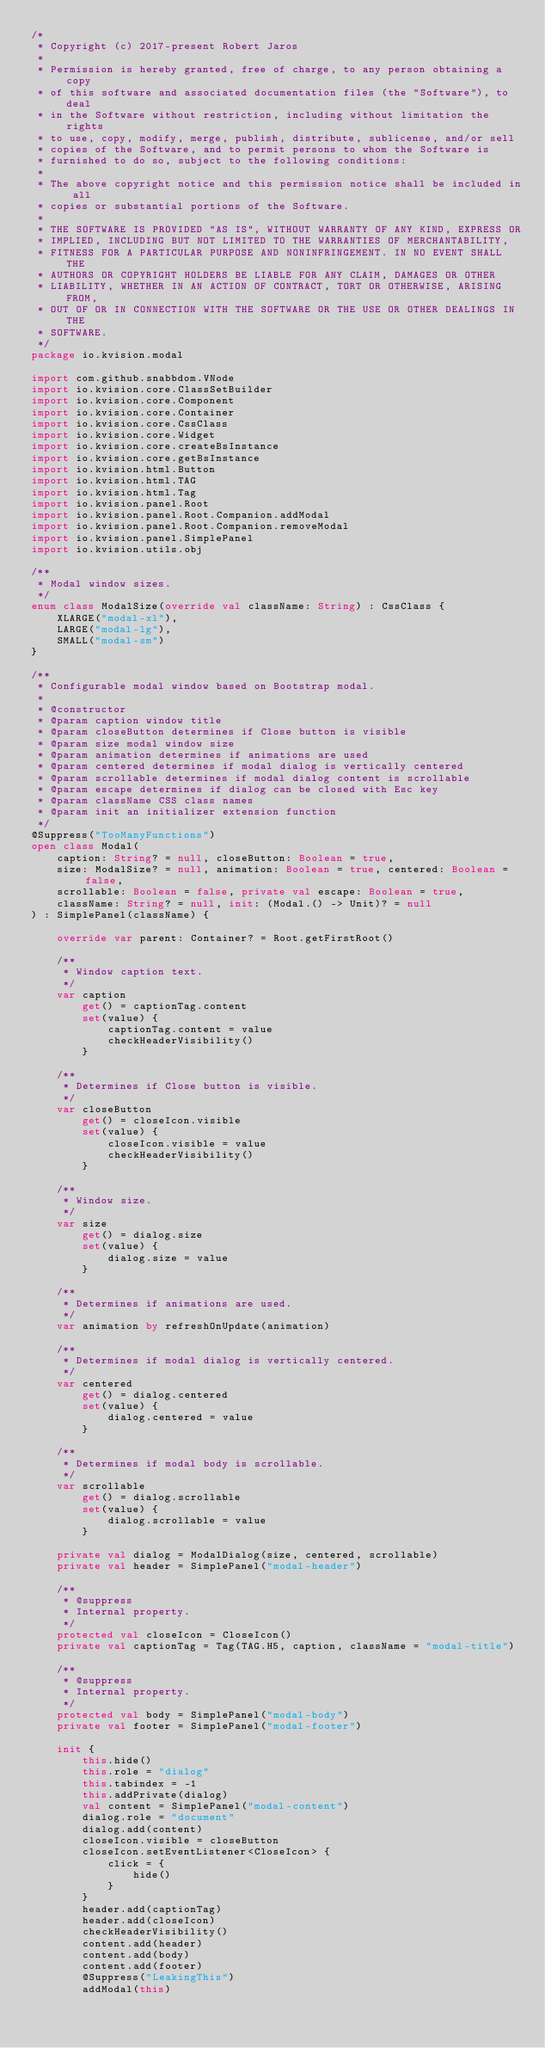<code> <loc_0><loc_0><loc_500><loc_500><_Kotlin_>/*
 * Copyright (c) 2017-present Robert Jaros
 *
 * Permission is hereby granted, free of charge, to any person obtaining a copy
 * of this software and associated documentation files (the "Software"), to deal
 * in the Software without restriction, including without limitation the rights
 * to use, copy, modify, merge, publish, distribute, sublicense, and/or sell
 * copies of the Software, and to permit persons to whom the Software is
 * furnished to do so, subject to the following conditions:
 *
 * The above copyright notice and this permission notice shall be included in all
 * copies or substantial portions of the Software.
 *
 * THE SOFTWARE IS PROVIDED "AS IS", WITHOUT WARRANTY OF ANY KIND, EXPRESS OR
 * IMPLIED, INCLUDING BUT NOT LIMITED TO THE WARRANTIES OF MERCHANTABILITY,
 * FITNESS FOR A PARTICULAR PURPOSE AND NONINFRINGEMENT. IN NO EVENT SHALL THE
 * AUTHORS OR COPYRIGHT HOLDERS BE LIABLE FOR ANY CLAIM, DAMAGES OR OTHER
 * LIABILITY, WHETHER IN AN ACTION OF CONTRACT, TORT OR OTHERWISE, ARISING FROM,
 * OUT OF OR IN CONNECTION WITH THE SOFTWARE OR THE USE OR OTHER DEALINGS IN THE
 * SOFTWARE.
 */
package io.kvision.modal

import com.github.snabbdom.VNode
import io.kvision.core.ClassSetBuilder
import io.kvision.core.Component
import io.kvision.core.Container
import io.kvision.core.CssClass
import io.kvision.core.Widget
import io.kvision.core.createBsInstance
import io.kvision.core.getBsInstance
import io.kvision.html.Button
import io.kvision.html.TAG
import io.kvision.html.Tag
import io.kvision.panel.Root
import io.kvision.panel.Root.Companion.addModal
import io.kvision.panel.Root.Companion.removeModal
import io.kvision.panel.SimplePanel
import io.kvision.utils.obj

/**
 * Modal window sizes.
 */
enum class ModalSize(override val className: String) : CssClass {
    XLARGE("modal-xl"),
    LARGE("modal-lg"),
    SMALL("modal-sm")
}

/**
 * Configurable modal window based on Bootstrap modal.
 *
 * @constructor
 * @param caption window title
 * @param closeButton determines if Close button is visible
 * @param size modal window size
 * @param animation determines if animations are used
 * @param centered determines if modal dialog is vertically centered
 * @param scrollable determines if modal dialog content is scrollable
 * @param escape determines if dialog can be closed with Esc key
 * @param className CSS class names
 * @param init an initializer extension function
 */
@Suppress("TooManyFunctions")
open class Modal(
    caption: String? = null, closeButton: Boolean = true,
    size: ModalSize? = null, animation: Boolean = true, centered: Boolean = false,
    scrollable: Boolean = false, private val escape: Boolean = true,
    className: String? = null, init: (Modal.() -> Unit)? = null
) : SimplePanel(className) {

    override var parent: Container? = Root.getFirstRoot()

    /**
     * Window caption text.
     */
    var caption
        get() = captionTag.content
        set(value) {
            captionTag.content = value
            checkHeaderVisibility()
        }

    /**
     * Determines if Close button is visible.
     */
    var closeButton
        get() = closeIcon.visible
        set(value) {
            closeIcon.visible = value
            checkHeaderVisibility()
        }

    /**
     * Window size.
     */
    var size
        get() = dialog.size
        set(value) {
            dialog.size = value
        }

    /**
     * Determines if animations are used.
     */
    var animation by refreshOnUpdate(animation)

    /**
     * Determines if modal dialog is vertically centered.
     */
    var centered
        get() = dialog.centered
        set(value) {
            dialog.centered = value
        }

    /**
     * Determines if modal body is scrollable.
     */
    var scrollable
        get() = dialog.scrollable
        set(value) {
            dialog.scrollable = value
        }

    private val dialog = ModalDialog(size, centered, scrollable)
    private val header = SimplePanel("modal-header")

    /**
     * @suppress
     * Internal property.
     */
    protected val closeIcon = CloseIcon()
    private val captionTag = Tag(TAG.H5, caption, className = "modal-title")

    /**
     * @suppress
     * Internal property.
     */
    protected val body = SimplePanel("modal-body")
    private val footer = SimplePanel("modal-footer")

    init {
        this.hide()
        this.role = "dialog"
        this.tabindex = -1
        this.addPrivate(dialog)
        val content = SimplePanel("modal-content")
        dialog.role = "document"
        dialog.add(content)
        closeIcon.visible = closeButton
        closeIcon.setEventListener<CloseIcon> {
            click = {
                hide()
            }
        }
        header.add(captionTag)
        header.add(closeIcon)
        checkHeaderVisibility()
        content.add(header)
        content.add(body)
        content.add(footer)
        @Suppress("LeakingThis")
        addModal(this)</code> 